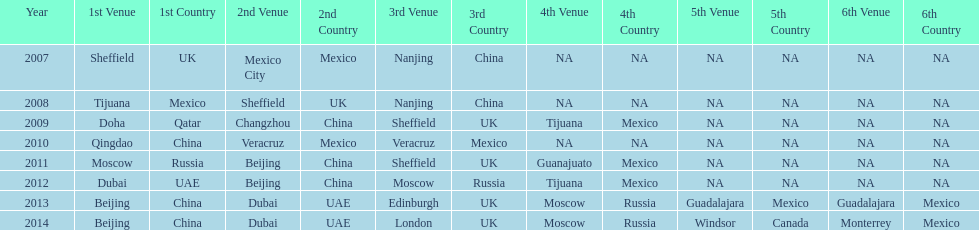What years had the most venues? 2013, 2014. 